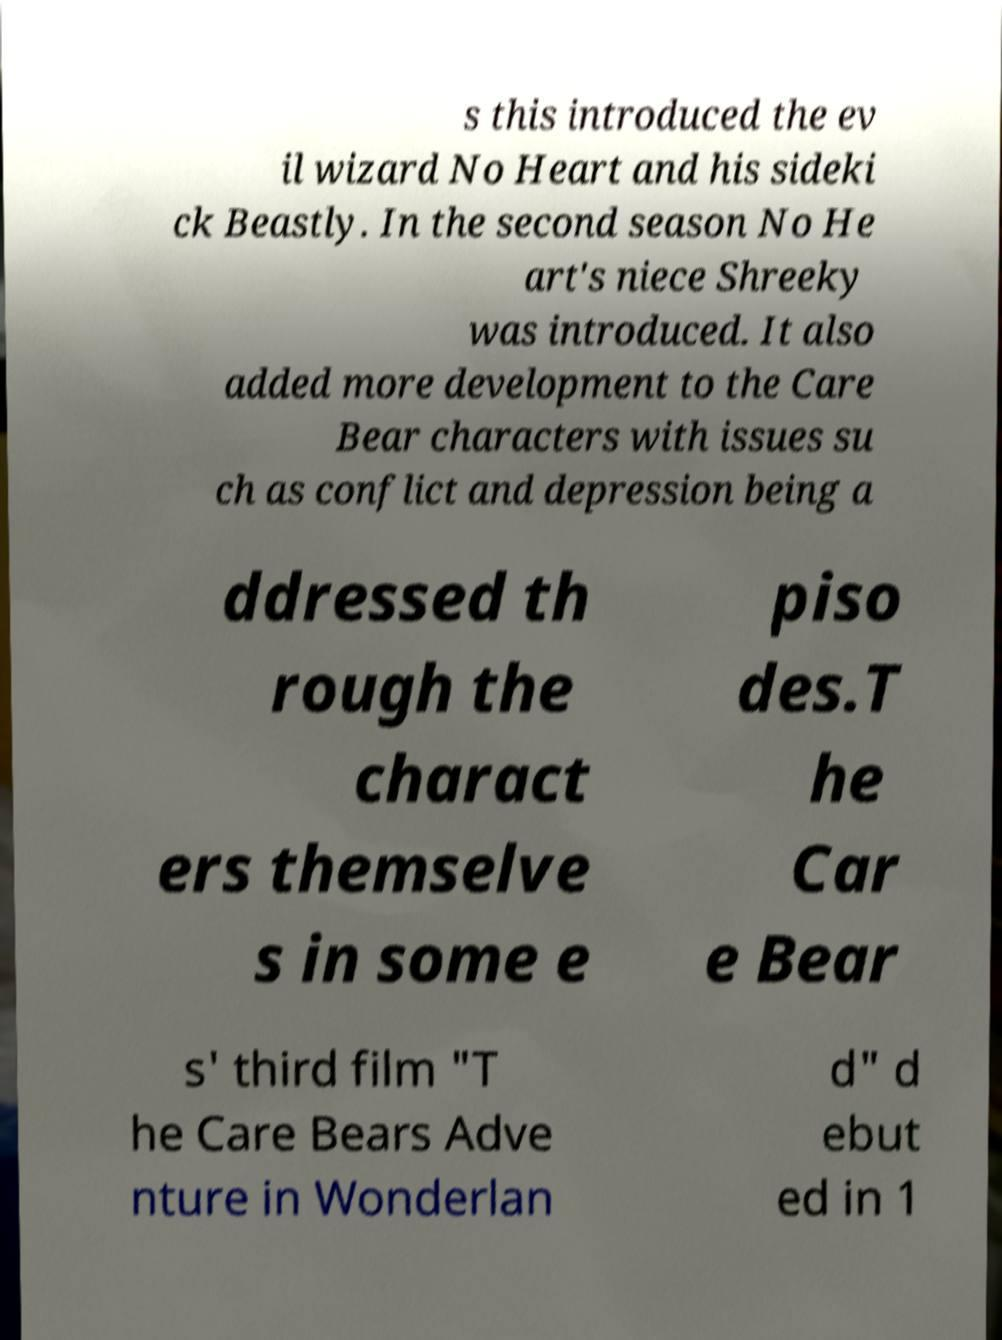There's text embedded in this image that I need extracted. Can you transcribe it verbatim? s this introduced the ev il wizard No Heart and his sideki ck Beastly. In the second season No He art's niece Shreeky was introduced. It also added more development to the Care Bear characters with issues su ch as conflict and depression being a ddressed th rough the charact ers themselve s in some e piso des.T he Car e Bear s' third film "T he Care Bears Adve nture in Wonderlan d" d ebut ed in 1 